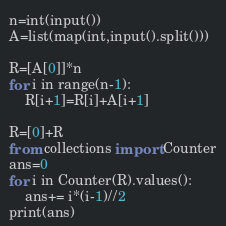<code> <loc_0><loc_0><loc_500><loc_500><_Python_>n=int(input())
A=list(map(int,input().split()))

R=[A[0]]*n
for i in range(n-1):
    R[i+1]=R[i]+A[i+1]

R=[0]+R
from collections import Counter
ans=0
for i in Counter(R).values():
    ans+= i*(i-1)//2
print(ans)</code> 